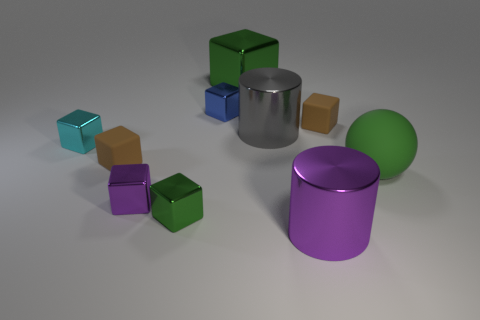Is there anything else that has the same color as the big shiny block?
Provide a short and direct response. Yes. Are there an equal number of things that are in front of the small green metal object and rubber balls that are to the left of the gray thing?
Your response must be concise. No. Are there more tiny cyan objects in front of the green rubber thing than big blue shiny cubes?
Provide a succinct answer. No. What number of objects are either green metal things in front of the large green sphere or big matte cylinders?
Give a very brief answer. 1. How many small cubes have the same material as the green sphere?
Offer a very short reply. 2. What is the shape of the big rubber thing that is the same color as the big metallic block?
Make the answer very short. Sphere. Is there another tiny purple thing that has the same shape as the small purple object?
Your answer should be very brief. No. There is a gray object that is the same size as the ball; what is its shape?
Your response must be concise. Cylinder. There is a ball; is its color the same as the metallic block in front of the small purple object?
Offer a terse response. Yes. What number of brown rubber things are behind the small rubber cube that is to the left of the blue metal object?
Provide a short and direct response. 1. 